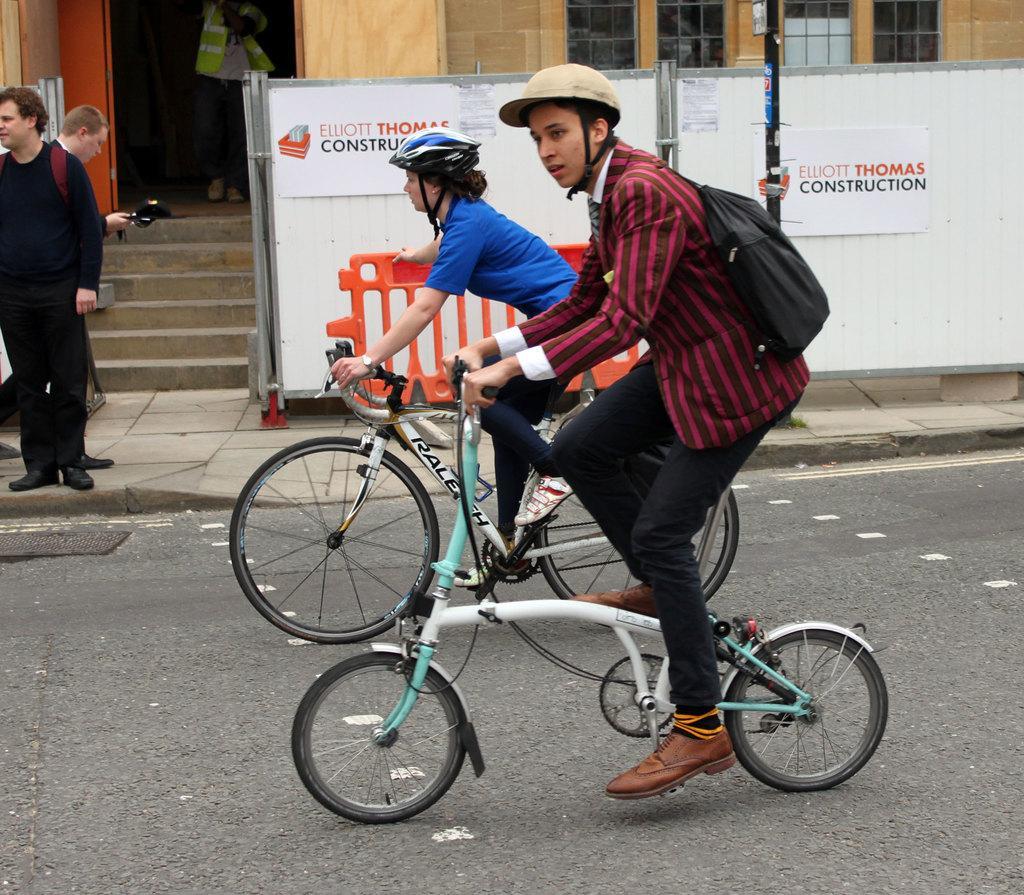Could you give a brief overview of what you see in this image? In this image we can see a two persons riding a bicycle on the road. There is a person standing on the top left side. In the background we can see two persons on the top left side. 